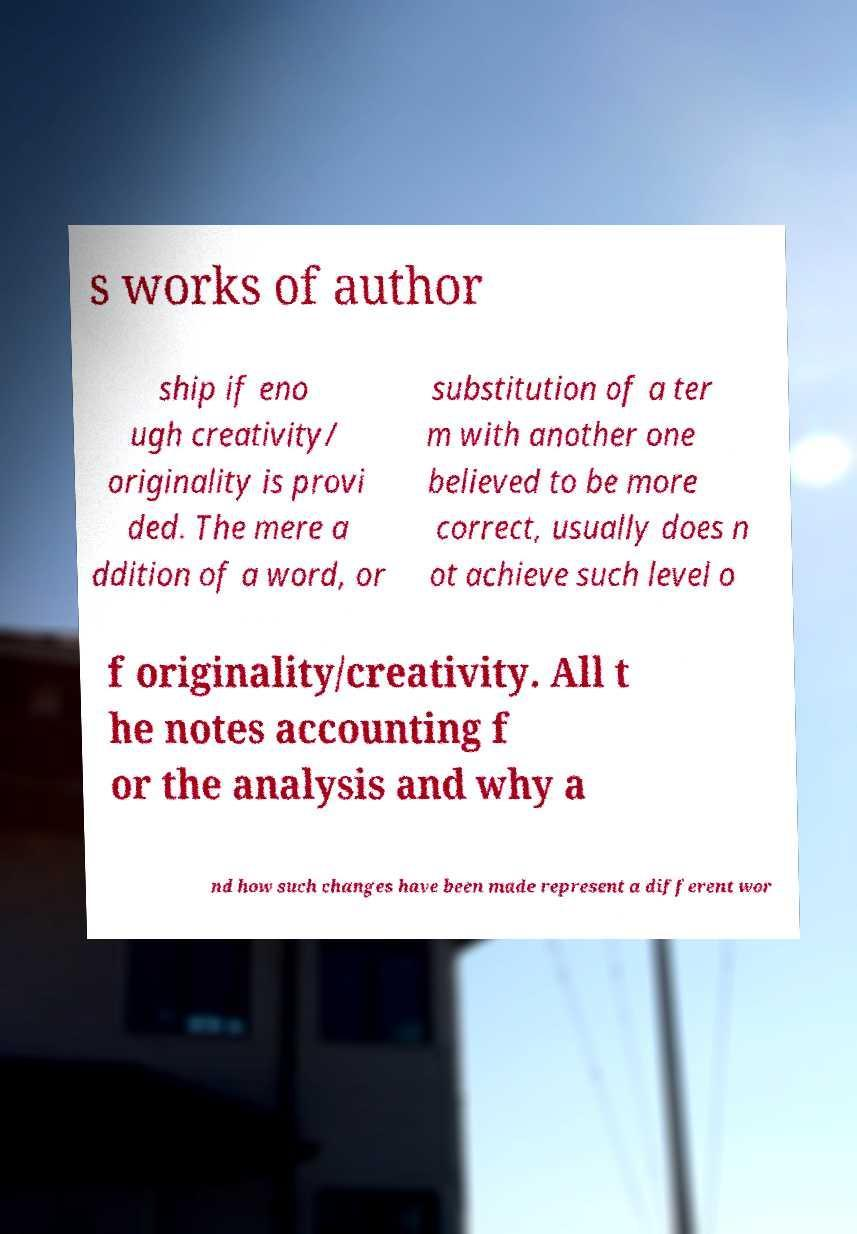Please identify and transcribe the text found in this image. s works of author ship if eno ugh creativity/ originality is provi ded. The mere a ddition of a word, or substitution of a ter m with another one believed to be more correct, usually does n ot achieve such level o f originality/creativity. All t he notes accounting f or the analysis and why a nd how such changes have been made represent a different wor 